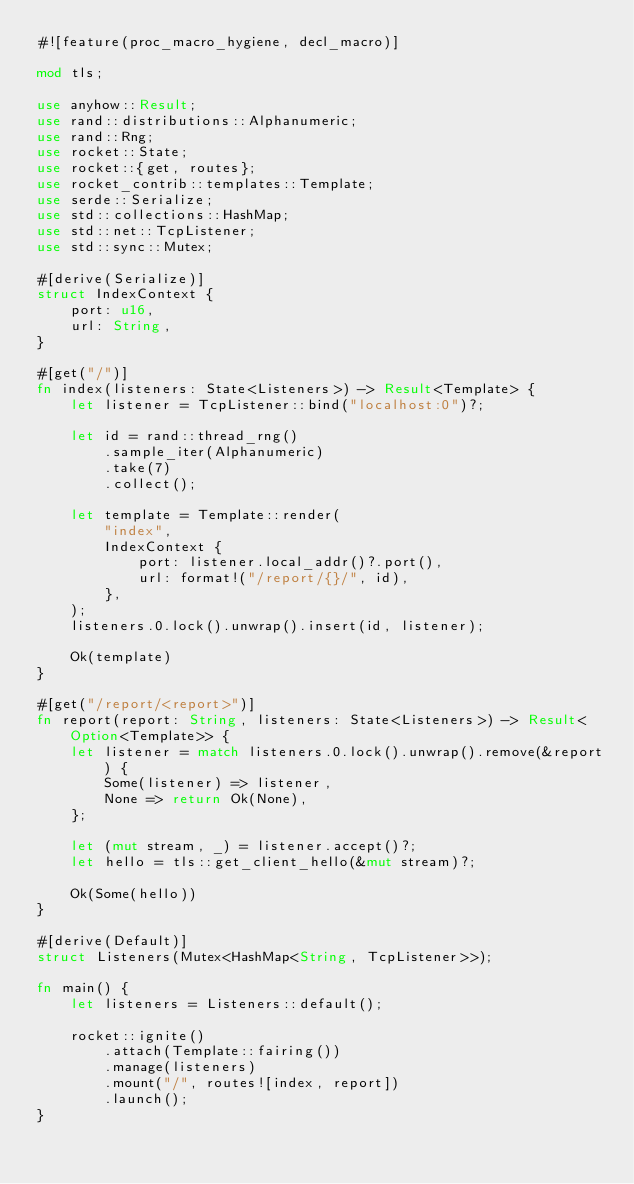<code> <loc_0><loc_0><loc_500><loc_500><_Rust_>#![feature(proc_macro_hygiene, decl_macro)]

mod tls;

use anyhow::Result;
use rand::distributions::Alphanumeric;
use rand::Rng;
use rocket::State;
use rocket::{get, routes};
use rocket_contrib::templates::Template;
use serde::Serialize;
use std::collections::HashMap;
use std::net::TcpListener;
use std::sync::Mutex;

#[derive(Serialize)]
struct IndexContext {
    port: u16,
    url: String,
}

#[get("/")]
fn index(listeners: State<Listeners>) -> Result<Template> {
    let listener = TcpListener::bind("localhost:0")?;

    let id = rand::thread_rng()
        .sample_iter(Alphanumeric)
        .take(7)
        .collect();

    let template = Template::render(
        "index",
        IndexContext {
            port: listener.local_addr()?.port(),
            url: format!("/report/{}/", id),
        },
    );
    listeners.0.lock().unwrap().insert(id, listener);

    Ok(template)
}

#[get("/report/<report>")]
fn report(report: String, listeners: State<Listeners>) -> Result<Option<Template>> {
    let listener = match listeners.0.lock().unwrap().remove(&report) {
        Some(listener) => listener,
        None => return Ok(None),
    };

    let (mut stream, _) = listener.accept()?;
    let hello = tls::get_client_hello(&mut stream)?;

    Ok(Some(hello))
}

#[derive(Default)]
struct Listeners(Mutex<HashMap<String, TcpListener>>);

fn main() {
    let listeners = Listeners::default();

    rocket::ignite()
        .attach(Template::fairing())
        .manage(listeners)
        .mount("/", routes![index, report])
        .launch();
}
</code> 